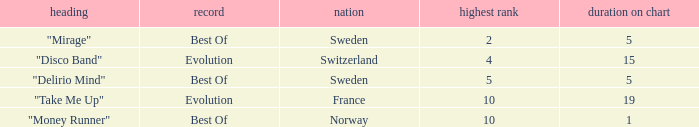What is the title of the single with the peak position of 10 and from France? "Take Me Up". 